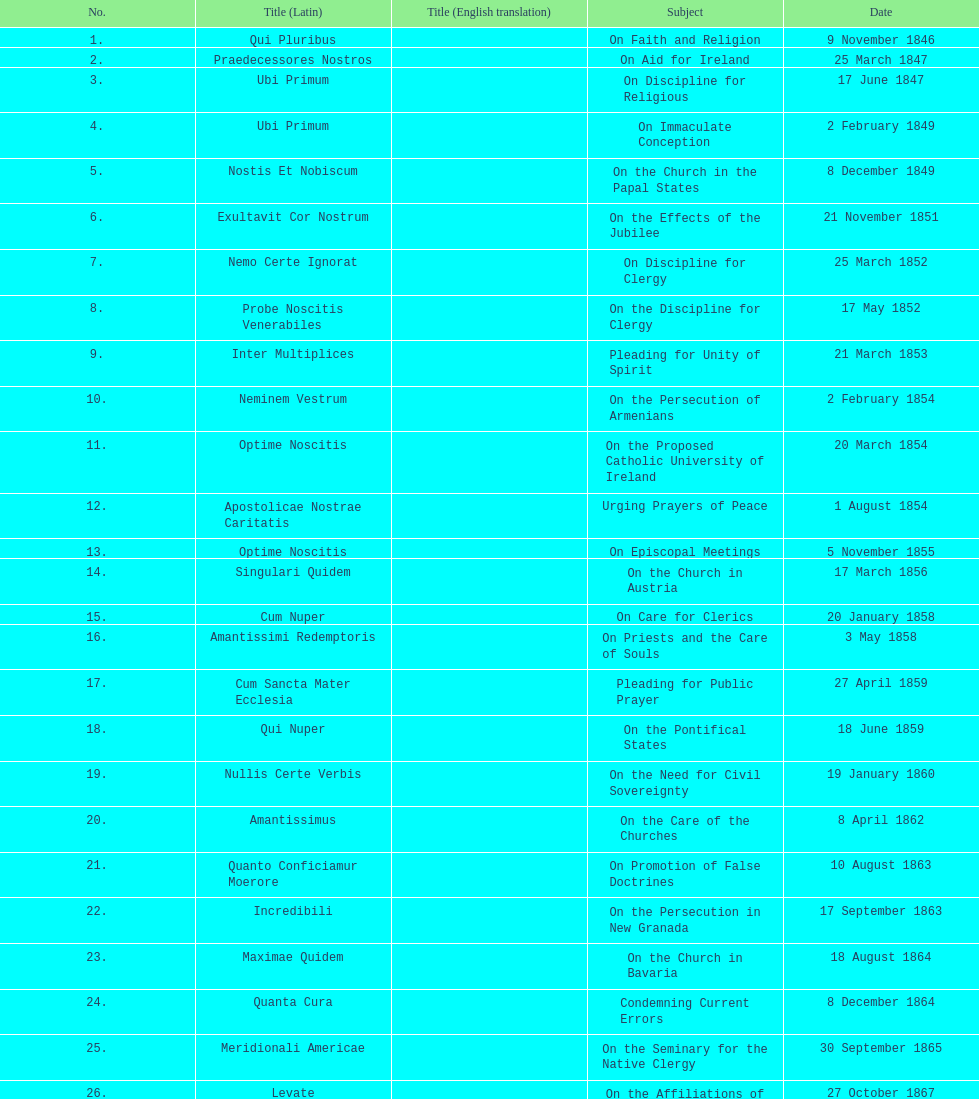What is the last title? Graves Ac Diuturnae. 